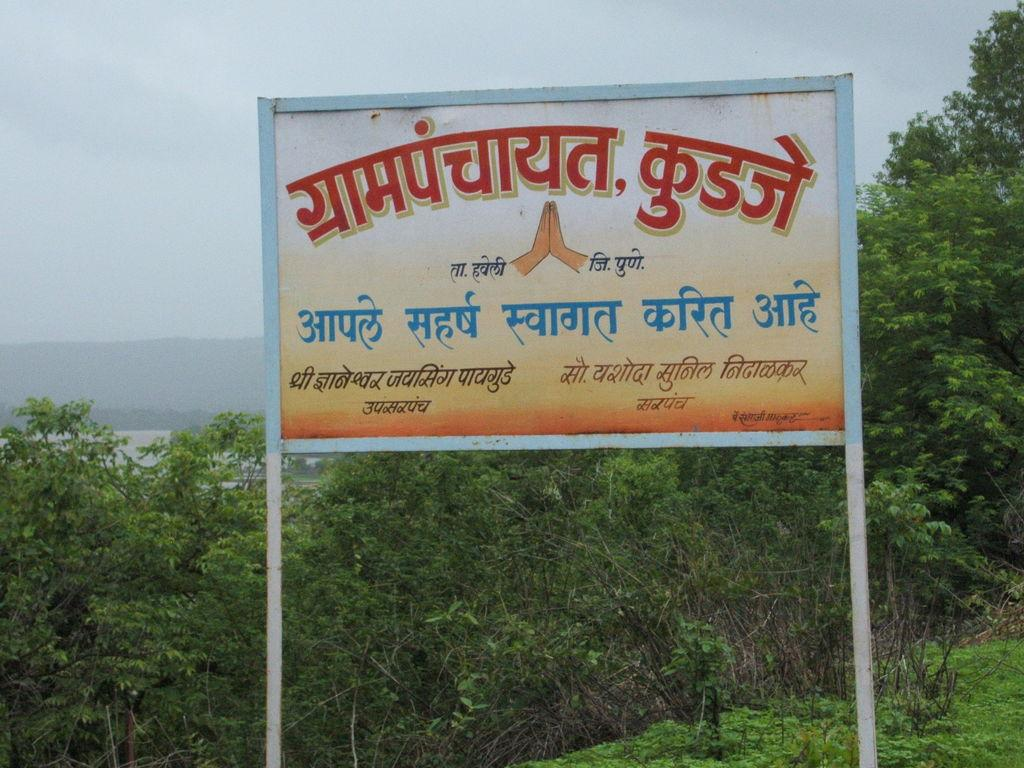What is attached to the pole in the image? There is a board attached to a pole in the image. What type of plants can be seen in the image? The plants in the image are green in color. What can be seen in the background of the image? There is water visible in the background of the image. How would you describe the sky in the image? The sky in the image has a white and blue color. What historical event is being commemorated by the board in the image? There is no indication of a historical event being commemorated by the board in the image. Is there any evidence of death or a funeral in the image? No, there is no evidence of death or a funeral in the image. Is there any fire visible in the image? No, there is no fire visible in the image. 